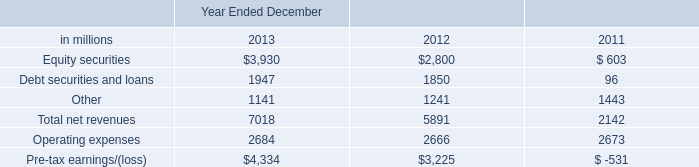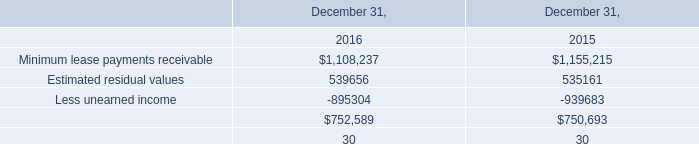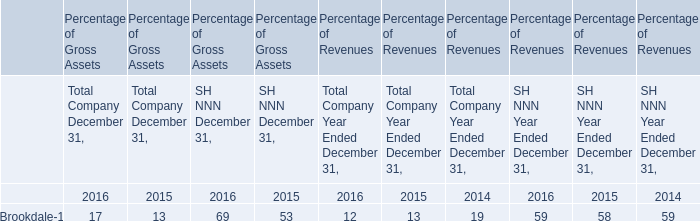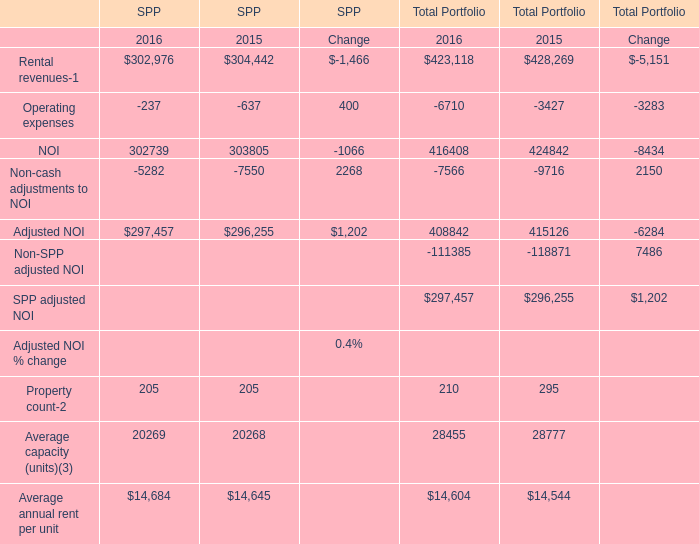what's the total amount of NOI of SPP 2016, Estimated residual values of December 31, 2016, and Less unearned income of December 31, 2016 ? 
Computations: ((302739.0 + 539656.0) + 895304.0)
Answer: 1737699.0. 